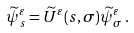<formula> <loc_0><loc_0><loc_500><loc_500>\widetilde { \psi } ^ { \varepsilon } _ { s } = \widetilde { U } ^ { \varepsilon } ( s , \sigma ) \widetilde { \psi } ^ { \varepsilon } _ { \sigma } \, .</formula> 